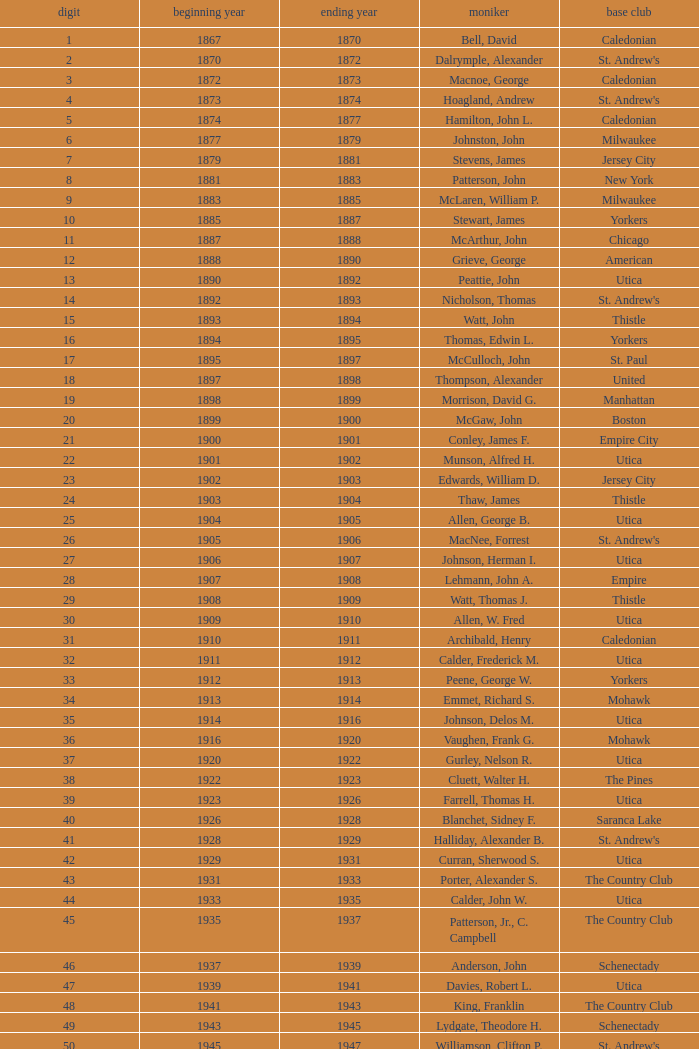Which Year Start has a Number of 28? 1907.0. 